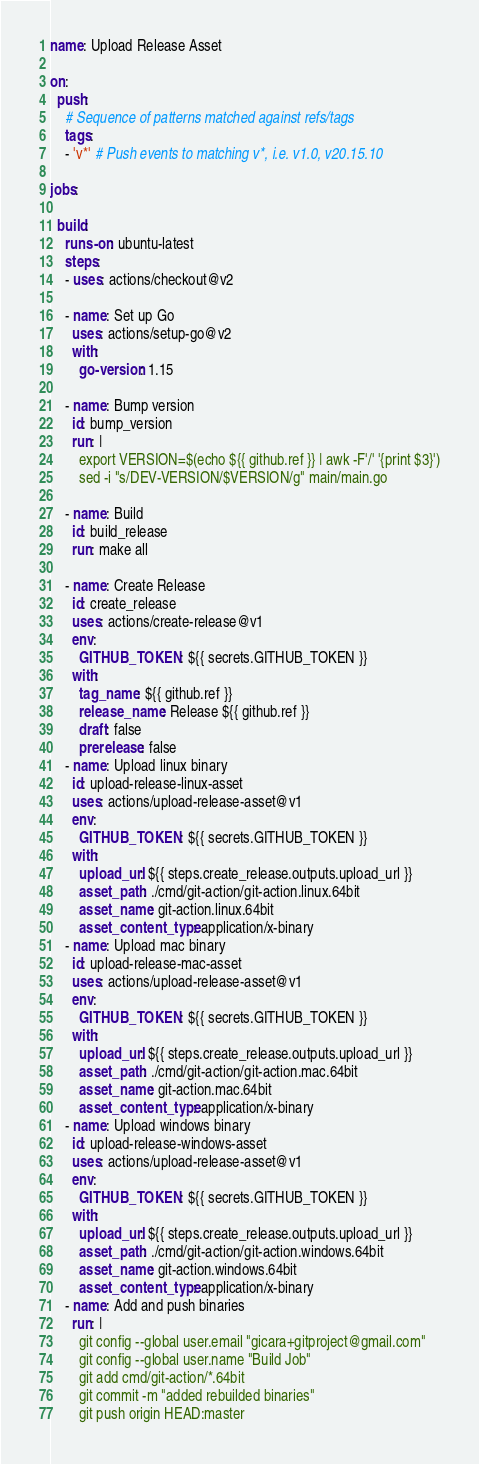Convert code to text. <code><loc_0><loc_0><loc_500><loc_500><_YAML_>
name: Upload Release Asset

on:
  push:
    # Sequence of patterns matched against refs/tags
    tags:
    - 'v*' # Push events to matching v*, i.e. v1.0, v20.15.10

jobs:

  build:
    runs-on: ubuntu-latest
    steps:
    - uses: actions/checkout@v2

    - name: Set up Go
      uses: actions/setup-go@v2
      with:
        go-version: 1.15

    - name: Bump version
      id: bump_version
      run: | 
        export VERSION=$(echo ${{ github.ref }} | awk -F'/' '{print $3}')
        sed -i "s/DEV-VERSION/$VERSION/g" main/main.go

    - name: Build
      id: build_release
      run: make all

    - name: Create Release
      id: create_release
      uses: actions/create-release@v1
      env:
        GITHUB_TOKEN: ${{ secrets.GITHUB_TOKEN }}
      with:
        tag_name: ${{ github.ref }}
        release_name: Release ${{ github.ref }}
        draft: false
        prerelease: false
    - name: Upload linux binary
      id: upload-release-linux-asset 
      uses: actions/upload-release-asset@v1
      env:
        GITHUB_TOKEN: ${{ secrets.GITHUB_TOKEN }}
      with:
        upload_url: ${{ steps.create_release.outputs.upload_url }} 
        asset_path: ./cmd/git-action/git-action.linux.64bit
        asset_name: git-action.linux.64bit
        asset_content_type: application/x-binary
    - name: Upload mac binary
      id: upload-release-mac-asset 
      uses: actions/upload-release-asset@v1
      env:
        GITHUB_TOKEN: ${{ secrets.GITHUB_TOKEN }}
      with:
        upload_url: ${{ steps.create_release.outputs.upload_url }} 
        asset_path: ./cmd/git-action/git-action.mac.64bit
        asset_name: git-action.mac.64bit
        asset_content_type: application/x-binary
    - name: Upload windows binary
      id: upload-release-windows-asset 
      uses: actions/upload-release-asset@v1
      env:
        GITHUB_TOKEN: ${{ secrets.GITHUB_TOKEN }}
      with:
        upload_url: ${{ steps.create_release.outputs.upload_url }} 
        asset_path: ./cmd/git-action/git-action.windows.64bit
        asset_name: git-action.windows.64bit
        asset_content_type: application/x-binary
    - name: Add and push binaries
      run: |
        git config --global user.email "gicara+gitproject@gmail.com"
        git config --global user.name "Build Job"
        git add cmd/git-action/*.64bit
        git commit -m "added rebuilded binaries"
        git push origin HEAD:master</code> 